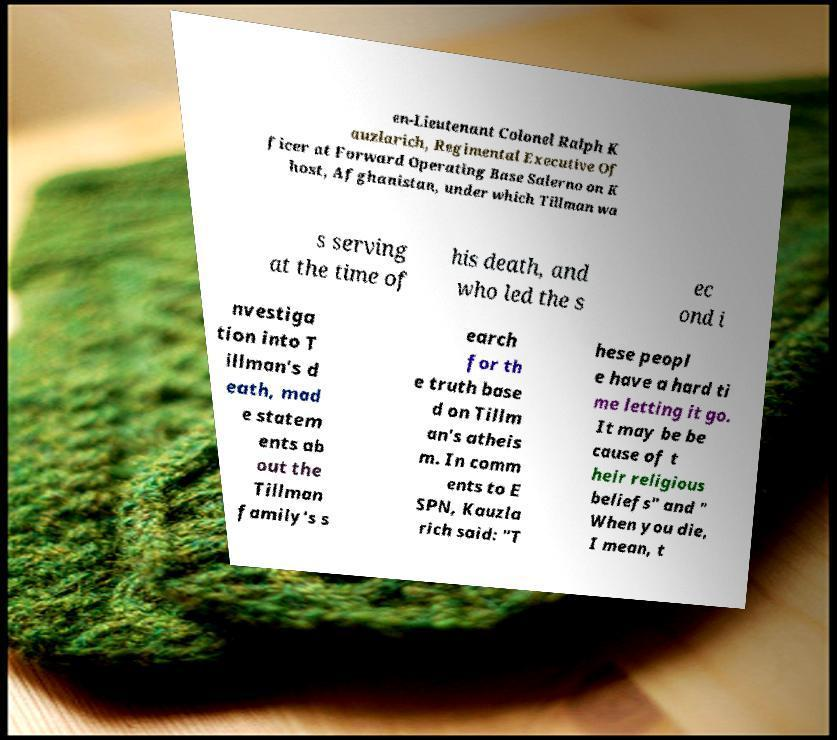There's text embedded in this image that I need extracted. Can you transcribe it verbatim? en-Lieutenant Colonel Ralph K auzlarich, Regimental Executive Of ficer at Forward Operating Base Salerno on K host, Afghanistan, under which Tillman wa s serving at the time of his death, and who led the s ec ond i nvestiga tion into T illman's d eath, mad e statem ents ab out the Tillman family's s earch for th e truth base d on Tillm an's atheis m. In comm ents to E SPN, Kauzla rich said: "T hese peopl e have a hard ti me letting it go. It may be be cause of t heir religious beliefs" and " When you die, I mean, t 